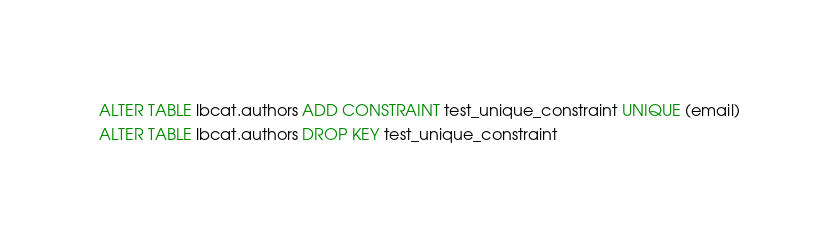Convert code to text. <code><loc_0><loc_0><loc_500><loc_500><_SQL_>ALTER TABLE lbcat.authors ADD CONSTRAINT test_unique_constraint UNIQUE (email)
ALTER TABLE lbcat.authors DROP KEY test_unique_constraint</code> 